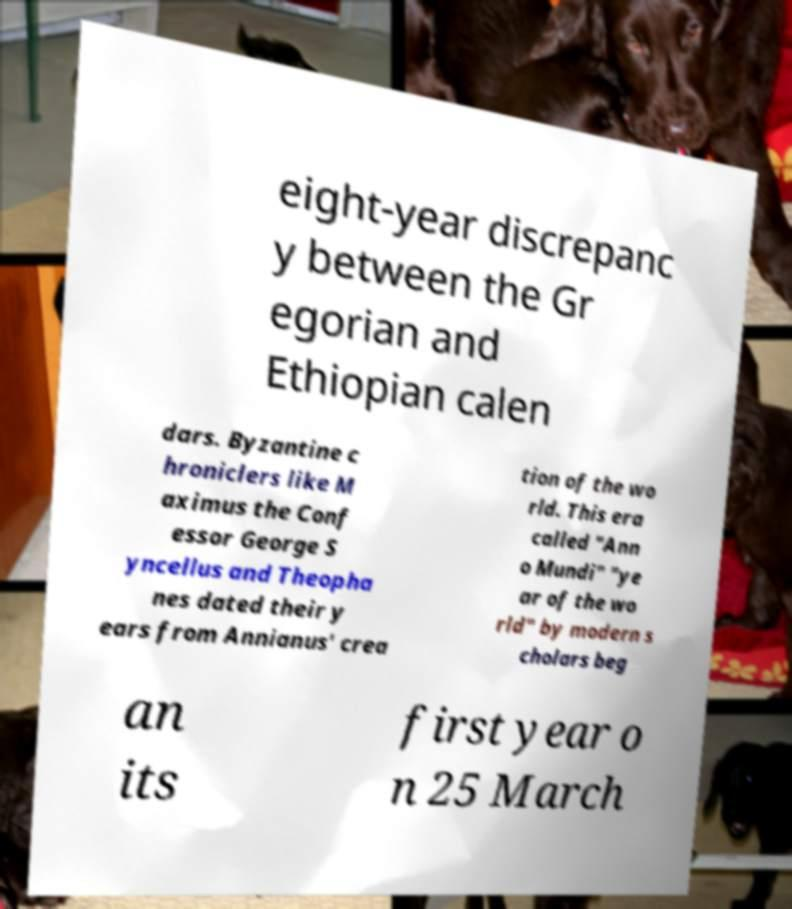Could you assist in decoding the text presented in this image and type it out clearly? eight-year discrepanc y between the Gr egorian and Ethiopian calen dars. Byzantine c hroniclers like M aximus the Conf essor George S yncellus and Theopha nes dated their y ears from Annianus' crea tion of the wo rld. This era called "Ann o Mundi" "ye ar of the wo rld" by modern s cholars beg an its first year o n 25 March 